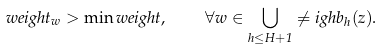<formula> <loc_0><loc_0><loc_500><loc_500>\ w e i g h t _ { w } > \min w e i g h t , \quad \forall w \in \bigcup _ { h \leq H + 1 } \ne i g h b _ { h } ( z ) .</formula> 